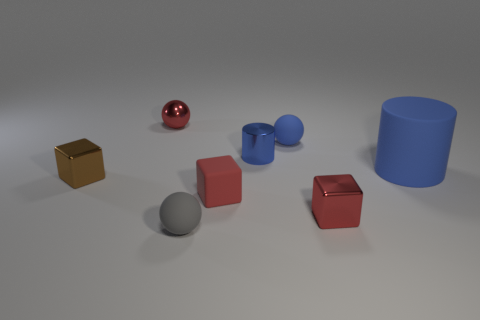Is there any other thing that is the same size as the blue rubber cylinder?
Provide a short and direct response. No. Do the tiny matte object that is on the left side of the tiny rubber cube and the large thing have the same color?
Provide a short and direct response. No. How big is the shiny block that is right of the small red object that is behind the blue rubber sphere?
Your response must be concise. Small. There is a blue thing that is the same size as the blue ball; what material is it?
Offer a terse response. Metal. How many other objects are the same size as the blue shiny cylinder?
Provide a succinct answer. 6. How many cubes are either blue metallic things or blue matte things?
Offer a terse response. 0. Are there any other things that are made of the same material as the blue sphere?
Offer a very short reply. Yes. What is the red object that is on the left side of the tiny ball that is in front of the metal block that is to the left of the blue metallic thing made of?
Ensure brevity in your answer.  Metal. There is a small ball that is the same color as the large thing; what material is it?
Keep it short and to the point. Rubber. What number of other gray objects are made of the same material as the gray object?
Your answer should be compact. 0. 